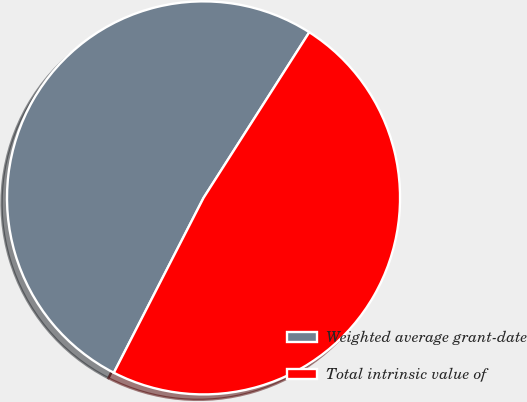Convert chart. <chart><loc_0><loc_0><loc_500><loc_500><pie_chart><fcel>Weighted average grant-date<fcel>Total intrinsic value of<nl><fcel>51.5%<fcel>48.5%<nl></chart> 